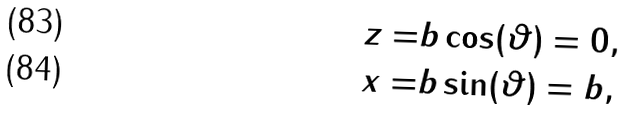<formula> <loc_0><loc_0><loc_500><loc_500>z = & b \cos ( \vartheta ) = 0 , \\ x = & b \sin ( \vartheta ) = b ,</formula> 